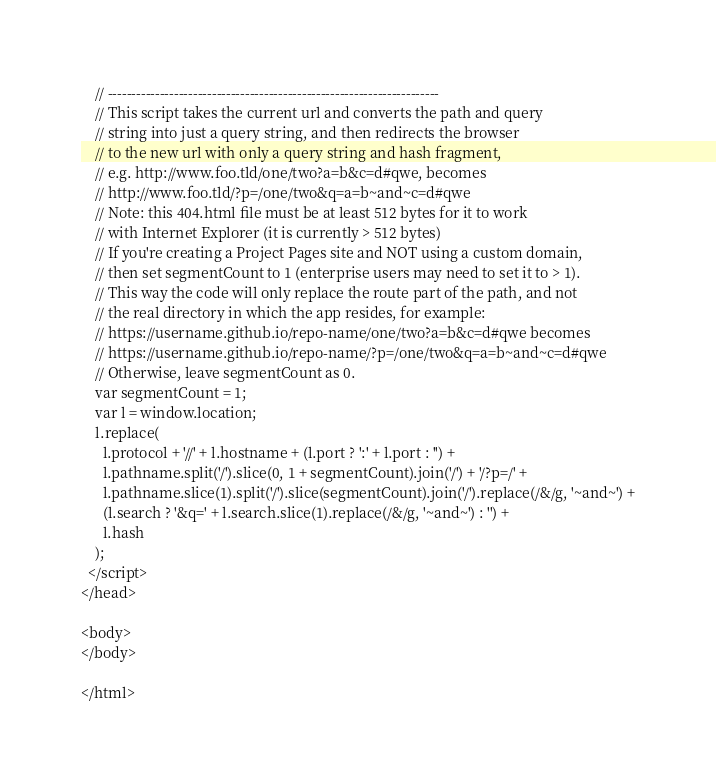Convert code to text. <code><loc_0><loc_0><loc_500><loc_500><_HTML_>    // ----------------------------------------------------------------------
    // This script takes the current url and converts the path and query
    // string into just a query string, and then redirects the browser
    // to the new url with only a query string and hash fragment,
    // e.g. http://www.foo.tld/one/two?a=b&c=d#qwe, becomes
    // http://www.foo.tld/?p=/one/two&q=a=b~and~c=d#qwe
    // Note: this 404.html file must be at least 512 bytes for it to work
    // with Internet Explorer (it is currently > 512 bytes)
    // If you're creating a Project Pages site and NOT using a custom domain,
    // then set segmentCount to 1 (enterprise users may need to set it to > 1).
    // This way the code will only replace the route part of the path, and not
    // the real directory in which the app resides, for example:
    // https://username.github.io/repo-name/one/two?a=b&c=d#qwe becomes
    // https://username.github.io/repo-name/?p=/one/two&q=a=b~and~c=d#qwe
    // Otherwise, leave segmentCount as 0.
    var segmentCount = 1;
    var l = window.location;
    l.replace(
      l.protocol + '//' + l.hostname + (l.port ? ':' + l.port : '') +
      l.pathname.split('/').slice(0, 1 + segmentCount).join('/') + '/?p=/' +
      l.pathname.slice(1).split('/').slice(segmentCount).join('/').replace(/&/g, '~and~') +
      (l.search ? '&q=' + l.search.slice(1).replace(/&/g, '~and~') : '') +
      l.hash
    );
  </script>
</head>

<body>
</body>

</html>
</code> 